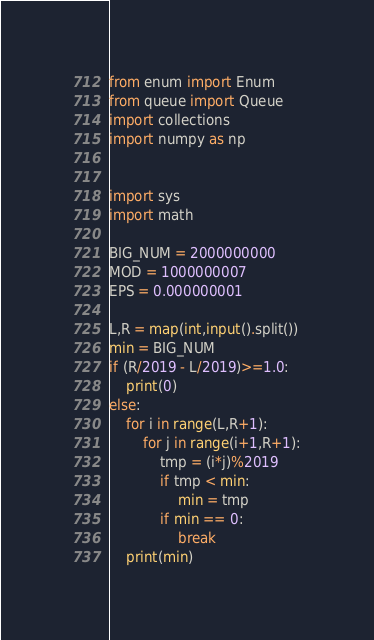<code> <loc_0><loc_0><loc_500><loc_500><_Python_>from enum import Enum
from queue import Queue
import collections
import numpy as np


import sys
import math

BIG_NUM = 2000000000
MOD = 1000000007
EPS = 0.000000001

L,R = map(int,input().split())
min = BIG_NUM
if (R/2019 - L/2019)>=1.0:
    print(0)
else:
    for i in range(L,R+1):
        for j in range(i+1,R+1):
            tmp = (i*j)%2019
            if tmp < min:
                min = tmp
            if min == 0:
                break
    print(min)
</code> 